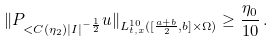<formula> <loc_0><loc_0><loc_500><loc_500>\| P _ { < C ( \eta _ { 2 } ) | I | ^ { - \frac { 1 } { 2 } } } u \| _ { L _ { t , x } ^ { 1 0 } ( [ \frac { a + b } 2 , b ] \times \Omega ) } \geq \frac { \eta _ { 0 } } { 1 0 } \, .</formula> 